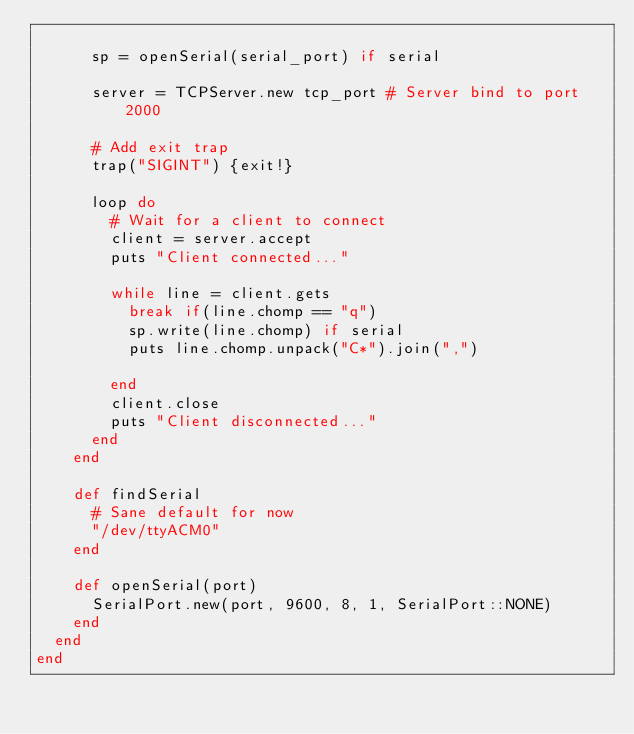Convert code to text. <code><loc_0><loc_0><loc_500><loc_500><_Ruby_>
      sp = openSerial(serial_port) if serial

      server = TCPServer.new tcp_port # Server bind to port 2000

      # Add exit trap
      trap("SIGINT") {exit!}

      loop do
        # Wait for a client to connect
        client = server.accept
        puts "Client connected..."

        while line = client.gets
          break if(line.chomp == "q")
          sp.write(line.chomp) if serial
          puts line.chomp.unpack("C*").join(",")

        end
        client.close
        puts "Client disconnected..."
      end
    end

    def findSerial
      # Sane default for now
      "/dev/ttyACM0"
    end

    def openSerial(port)
      SerialPort.new(port, 9600, 8, 1, SerialPort::NONE)
    end
  end
end
</code> 